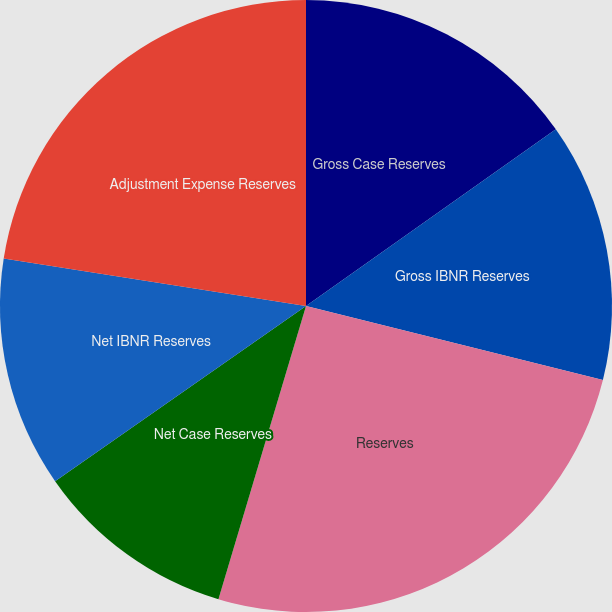<chart> <loc_0><loc_0><loc_500><loc_500><pie_chart><fcel>Gross Case Reserves<fcel>Gross IBNR Reserves<fcel>Reserves<fcel>Net Case Reserves<fcel>Net IBNR Reserves<fcel>Adjustment Expense Reserves<nl><fcel>15.2%<fcel>13.69%<fcel>25.73%<fcel>10.68%<fcel>12.18%<fcel>22.52%<nl></chart> 